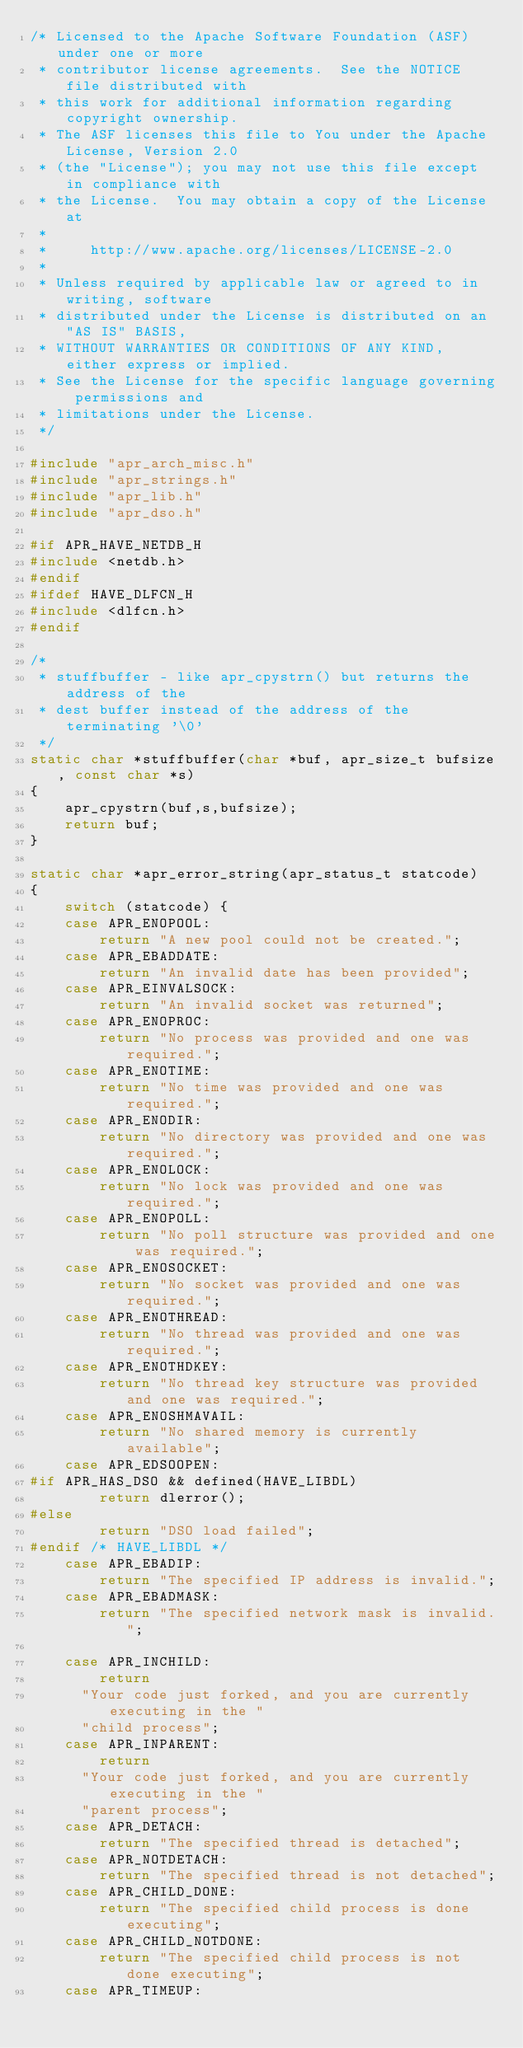Convert code to text. <code><loc_0><loc_0><loc_500><loc_500><_C_>/* Licensed to the Apache Software Foundation (ASF) under one or more
 * contributor license agreements.  See the NOTICE file distributed with
 * this work for additional information regarding copyright ownership.
 * The ASF licenses this file to You under the Apache License, Version 2.0
 * (the "License"); you may not use this file except in compliance with
 * the License.  You may obtain a copy of the License at
 *
 *     http://www.apache.org/licenses/LICENSE-2.0
 *
 * Unless required by applicable law or agreed to in writing, software
 * distributed under the License is distributed on an "AS IS" BASIS,
 * WITHOUT WARRANTIES OR CONDITIONS OF ANY KIND, either express or implied.
 * See the License for the specific language governing permissions and
 * limitations under the License.
 */

#include "apr_arch_misc.h"
#include "apr_strings.h"
#include "apr_lib.h"
#include "apr_dso.h"

#if APR_HAVE_NETDB_H
#include <netdb.h>
#endif
#ifdef HAVE_DLFCN_H
#include <dlfcn.h>
#endif

/*
 * stuffbuffer - like apr_cpystrn() but returns the address of the
 * dest buffer instead of the address of the terminating '\0'
 */
static char *stuffbuffer(char *buf, apr_size_t bufsize, const char *s)
{
    apr_cpystrn(buf,s,bufsize);
    return buf;
}

static char *apr_error_string(apr_status_t statcode)
{
    switch (statcode) {
    case APR_ENOPOOL:
        return "A new pool could not be created.";
    case APR_EBADDATE:
        return "An invalid date has been provided";
    case APR_EINVALSOCK:
        return "An invalid socket was returned";
    case APR_ENOPROC:
        return "No process was provided and one was required.";
    case APR_ENOTIME:
        return "No time was provided and one was required.";
    case APR_ENODIR:
        return "No directory was provided and one was required.";
    case APR_ENOLOCK:
        return "No lock was provided and one was required.";
    case APR_ENOPOLL:
        return "No poll structure was provided and one was required.";
    case APR_ENOSOCKET:
        return "No socket was provided and one was required.";
    case APR_ENOTHREAD:
        return "No thread was provided and one was required.";
    case APR_ENOTHDKEY:
        return "No thread key structure was provided and one was required.";
    case APR_ENOSHMAVAIL:
        return "No shared memory is currently available";
    case APR_EDSOOPEN:
#if APR_HAS_DSO && defined(HAVE_LIBDL)
        return dlerror();
#else
        return "DSO load failed";
#endif /* HAVE_LIBDL */
    case APR_EBADIP:
        return "The specified IP address is invalid.";
    case APR_EBADMASK:
        return "The specified network mask is invalid.";

    case APR_INCHILD:
        return
	    "Your code just forked, and you are currently executing in the "
	    "child process";
    case APR_INPARENT:
        return
	    "Your code just forked, and you are currently executing in the "
	    "parent process";
    case APR_DETACH:
        return "The specified thread is detached";
    case APR_NOTDETACH:
        return "The specified thread is not detached";
    case APR_CHILD_DONE:
        return "The specified child process is done executing";
    case APR_CHILD_NOTDONE:
        return "The specified child process is not done executing";
    case APR_TIMEUP:</code> 